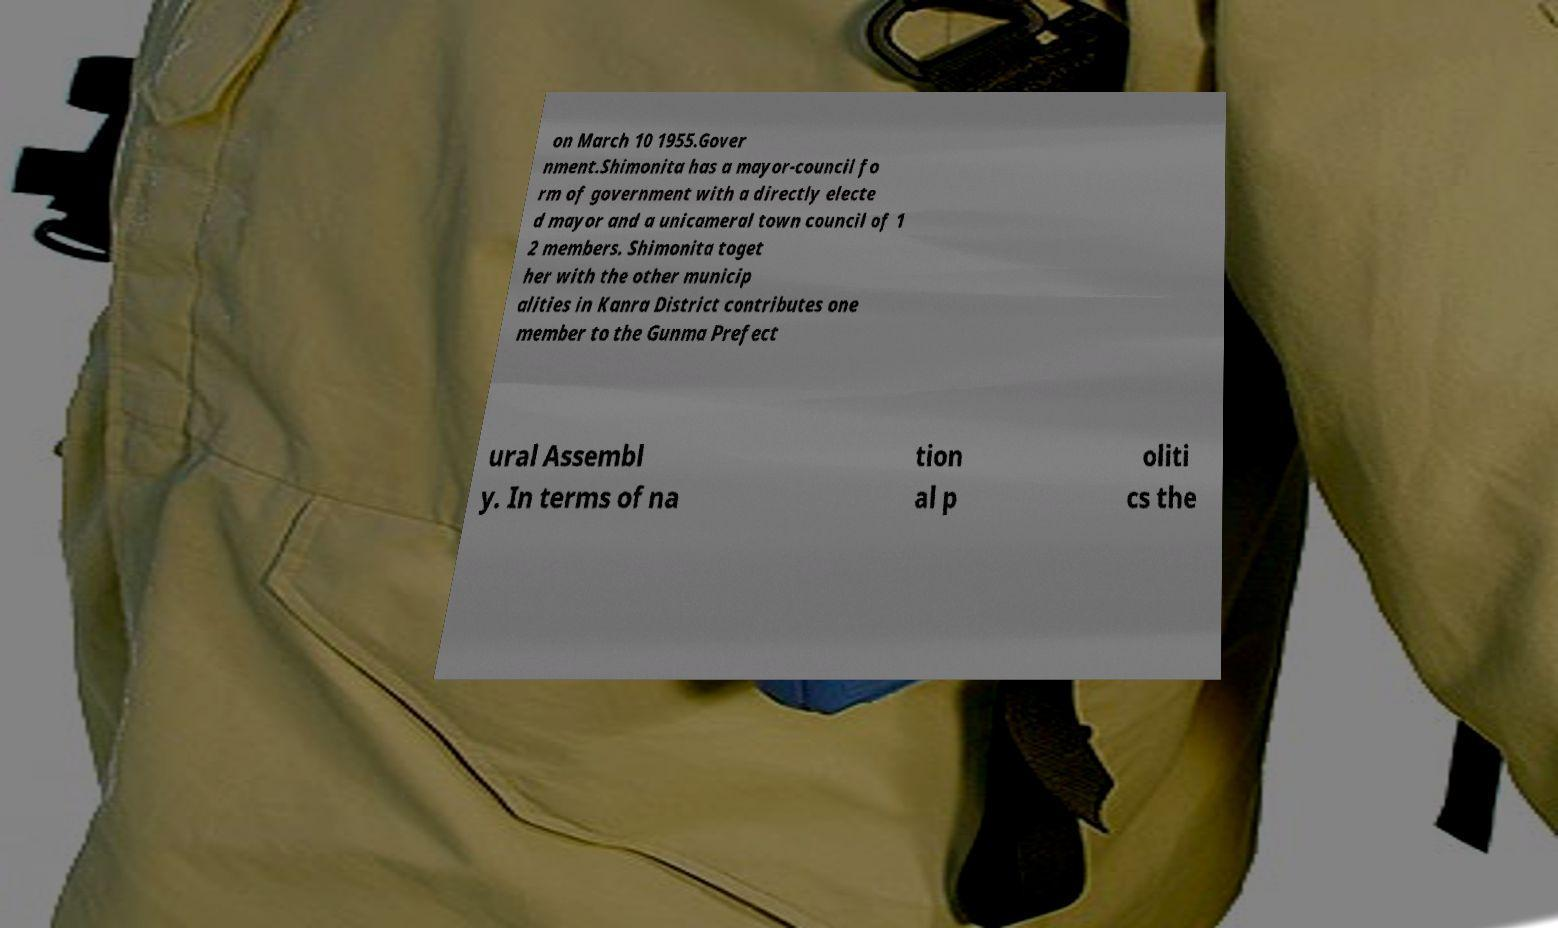Please read and relay the text visible in this image. What does it say? on March 10 1955.Gover nment.Shimonita has a mayor-council fo rm of government with a directly electe d mayor and a unicameral town council of 1 2 members. Shimonita toget her with the other municip alities in Kanra District contributes one member to the Gunma Prefect ural Assembl y. In terms of na tion al p oliti cs the 